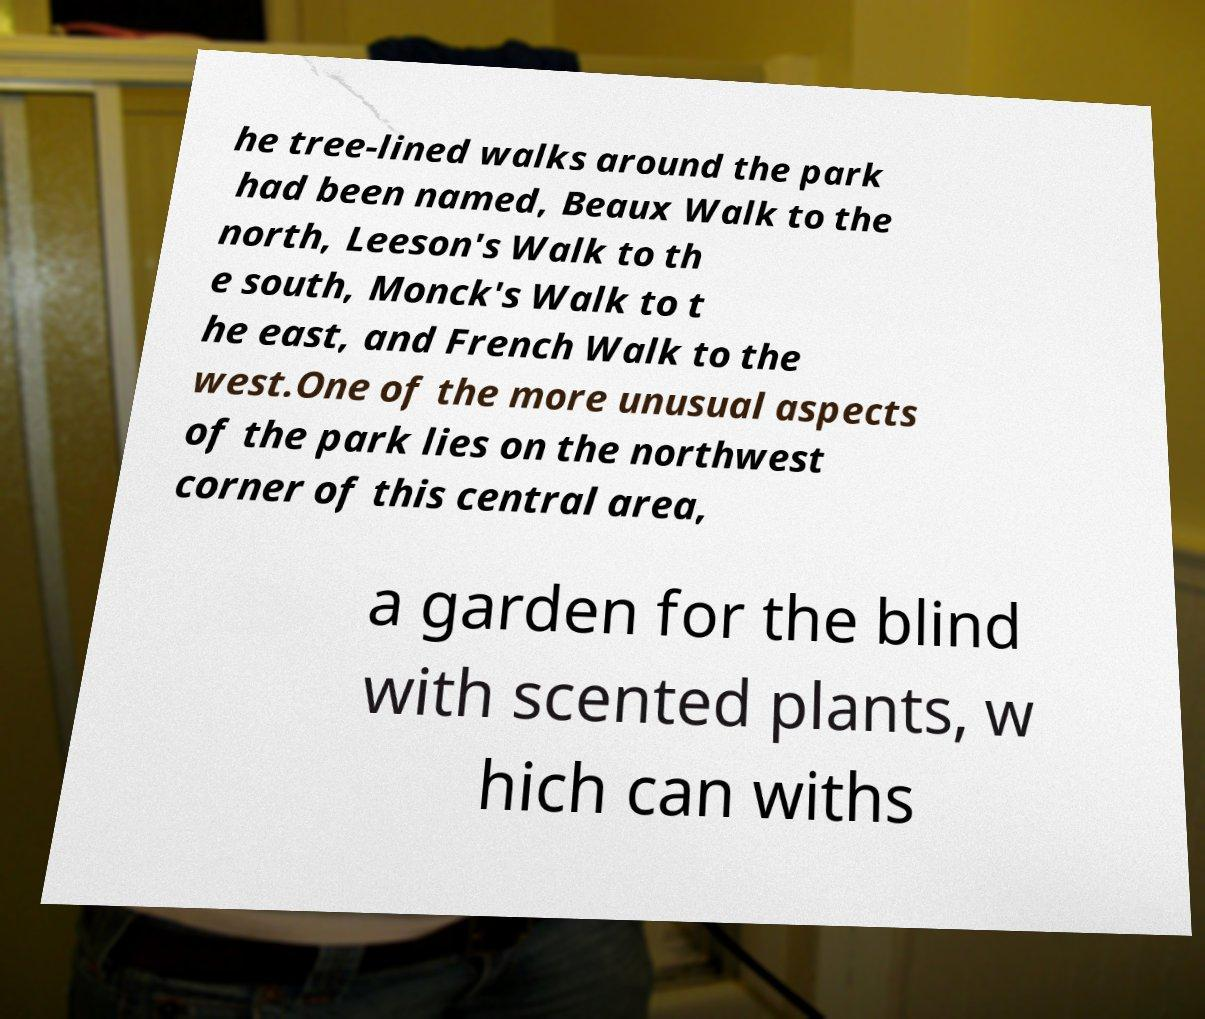Please identify and transcribe the text found in this image. he tree-lined walks around the park had been named, Beaux Walk to the north, Leeson's Walk to th e south, Monck's Walk to t he east, and French Walk to the west.One of the more unusual aspects of the park lies on the northwest corner of this central area, a garden for the blind with scented plants, w hich can withs 